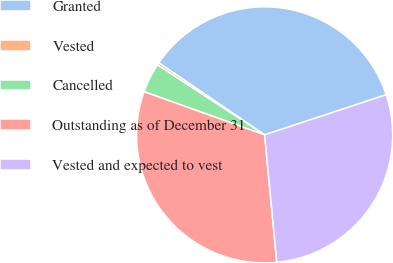<chart> <loc_0><loc_0><loc_500><loc_500><pie_chart><fcel>Granted<fcel>Vested<fcel>Cancelled<fcel>Outstanding as of December 31<fcel>Vested and expected to vest<nl><fcel>35.41%<fcel>0.31%<fcel>3.73%<fcel>31.99%<fcel>28.56%<nl></chart> 